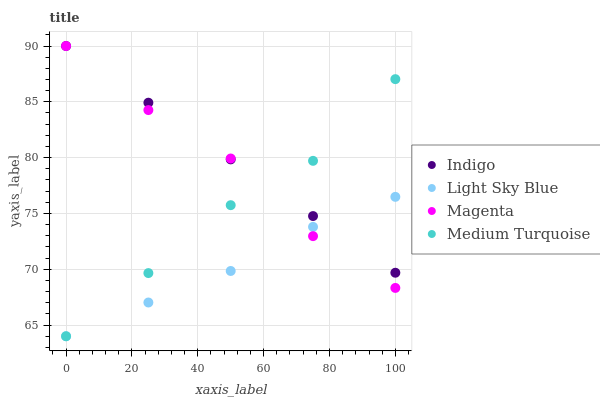Does Light Sky Blue have the minimum area under the curve?
Answer yes or no. Yes. Does Indigo have the maximum area under the curve?
Answer yes or no. Yes. Does Indigo have the minimum area under the curve?
Answer yes or no. No. Does Light Sky Blue have the maximum area under the curve?
Answer yes or no. No. Is Indigo the smoothest?
Answer yes or no. Yes. Is Magenta the roughest?
Answer yes or no. Yes. Is Light Sky Blue the smoothest?
Answer yes or no. No. Is Light Sky Blue the roughest?
Answer yes or no. No. Does Light Sky Blue have the lowest value?
Answer yes or no. Yes. Does Indigo have the lowest value?
Answer yes or no. No. Does Indigo have the highest value?
Answer yes or no. Yes. Does Light Sky Blue have the highest value?
Answer yes or no. No. Does Medium Turquoise intersect Indigo?
Answer yes or no. Yes. Is Medium Turquoise less than Indigo?
Answer yes or no. No. Is Medium Turquoise greater than Indigo?
Answer yes or no. No. 